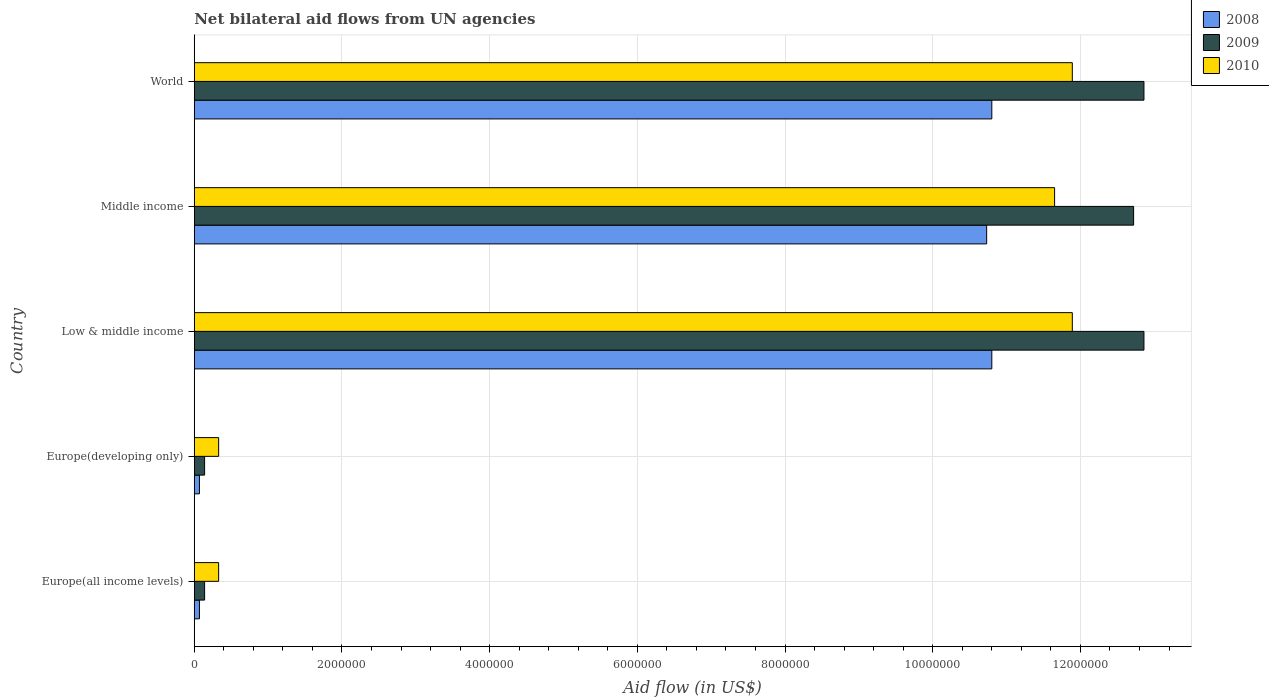How many different coloured bars are there?
Offer a very short reply. 3. Are the number of bars per tick equal to the number of legend labels?
Give a very brief answer. Yes. Are the number of bars on each tick of the Y-axis equal?
Give a very brief answer. Yes. How many bars are there on the 4th tick from the top?
Your answer should be very brief. 3. What is the label of the 3rd group of bars from the top?
Your answer should be compact. Low & middle income. Across all countries, what is the maximum net bilateral aid flow in 2010?
Offer a very short reply. 1.19e+07. Across all countries, what is the minimum net bilateral aid flow in 2010?
Provide a succinct answer. 3.30e+05. In which country was the net bilateral aid flow in 2010 maximum?
Your answer should be compact. Low & middle income. In which country was the net bilateral aid flow in 2010 minimum?
Your response must be concise. Europe(all income levels). What is the total net bilateral aid flow in 2010 in the graph?
Offer a terse response. 3.61e+07. What is the difference between the net bilateral aid flow in 2010 in Low & middle income and that in World?
Your response must be concise. 0. What is the difference between the net bilateral aid flow in 2009 in Middle income and the net bilateral aid flow in 2008 in World?
Offer a very short reply. 1.92e+06. What is the average net bilateral aid flow in 2009 per country?
Your answer should be compact. 7.74e+06. What is the ratio of the net bilateral aid flow in 2010 in Middle income to that in World?
Your answer should be compact. 0.98. Is the difference between the net bilateral aid flow in 2010 in Europe(all income levels) and World greater than the difference between the net bilateral aid flow in 2009 in Europe(all income levels) and World?
Keep it short and to the point. Yes. What is the difference between the highest and the second highest net bilateral aid flow in 2009?
Your answer should be very brief. 0. What is the difference between the highest and the lowest net bilateral aid flow in 2010?
Offer a very short reply. 1.16e+07. In how many countries, is the net bilateral aid flow in 2009 greater than the average net bilateral aid flow in 2009 taken over all countries?
Provide a succinct answer. 3. Is the sum of the net bilateral aid flow in 2008 in Europe(developing only) and World greater than the maximum net bilateral aid flow in 2010 across all countries?
Ensure brevity in your answer.  No. What does the 3rd bar from the top in Low & middle income represents?
Provide a short and direct response. 2008. What does the 3rd bar from the bottom in Middle income represents?
Provide a succinct answer. 2010. Is it the case that in every country, the sum of the net bilateral aid flow in 2010 and net bilateral aid flow in 2008 is greater than the net bilateral aid flow in 2009?
Ensure brevity in your answer.  Yes. How many countries are there in the graph?
Give a very brief answer. 5. Does the graph contain any zero values?
Provide a succinct answer. No. Does the graph contain grids?
Offer a terse response. Yes. Where does the legend appear in the graph?
Provide a succinct answer. Top right. How are the legend labels stacked?
Make the answer very short. Vertical. What is the title of the graph?
Your answer should be compact. Net bilateral aid flows from UN agencies. Does "1960" appear as one of the legend labels in the graph?
Provide a short and direct response. No. What is the label or title of the X-axis?
Offer a very short reply. Aid flow (in US$). What is the label or title of the Y-axis?
Offer a terse response. Country. What is the Aid flow (in US$) of 2008 in Europe(all income levels)?
Provide a succinct answer. 7.00e+04. What is the Aid flow (in US$) in 2009 in Europe(all income levels)?
Give a very brief answer. 1.40e+05. What is the Aid flow (in US$) of 2010 in Europe(all income levels)?
Your answer should be very brief. 3.30e+05. What is the Aid flow (in US$) of 2008 in Europe(developing only)?
Your response must be concise. 7.00e+04. What is the Aid flow (in US$) of 2008 in Low & middle income?
Your answer should be very brief. 1.08e+07. What is the Aid flow (in US$) in 2009 in Low & middle income?
Offer a terse response. 1.29e+07. What is the Aid flow (in US$) of 2010 in Low & middle income?
Provide a succinct answer. 1.19e+07. What is the Aid flow (in US$) of 2008 in Middle income?
Your answer should be very brief. 1.07e+07. What is the Aid flow (in US$) of 2009 in Middle income?
Offer a terse response. 1.27e+07. What is the Aid flow (in US$) in 2010 in Middle income?
Offer a very short reply. 1.16e+07. What is the Aid flow (in US$) in 2008 in World?
Make the answer very short. 1.08e+07. What is the Aid flow (in US$) in 2009 in World?
Keep it short and to the point. 1.29e+07. What is the Aid flow (in US$) in 2010 in World?
Provide a succinct answer. 1.19e+07. Across all countries, what is the maximum Aid flow (in US$) in 2008?
Your answer should be compact. 1.08e+07. Across all countries, what is the maximum Aid flow (in US$) of 2009?
Provide a succinct answer. 1.29e+07. Across all countries, what is the maximum Aid flow (in US$) of 2010?
Give a very brief answer. 1.19e+07. Across all countries, what is the minimum Aid flow (in US$) in 2008?
Ensure brevity in your answer.  7.00e+04. What is the total Aid flow (in US$) of 2008 in the graph?
Offer a very short reply. 3.25e+07. What is the total Aid flow (in US$) in 2009 in the graph?
Your response must be concise. 3.87e+07. What is the total Aid flow (in US$) in 2010 in the graph?
Your response must be concise. 3.61e+07. What is the difference between the Aid flow (in US$) of 2008 in Europe(all income levels) and that in Europe(developing only)?
Your response must be concise. 0. What is the difference between the Aid flow (in US$) in 2008 in Europe(all income levels) and that in Low & middle income?
Provide a succinct answer. -1.07e+07. What is the difference between the Aid flow (in US$) in 2009 in Europe(all income levels) and that in Low & middle income?
Your answer should be compact. -1.27e+07. What is the difference between the Aid flow (in US$) of 2010 in Europe(all income levels) and that in Low & middle income?
Offer a very short reply. -1.16e+07. What is the difference between the Aid flow (in US$) of 2008 in Europe(all income levels) and that in Middle income?
Keep it short and to the point. -1.07e+07. What is the difference between the Aid flow (in US$) in 2009 in Europe(all income levels) and that in Middle income?
Your answer should be very brief. -1.26e+07. What is the difference between the Aid flow (in US$) of 2010 in Europe(all income levels) and that in Middle income?
Give a very brief answer. -1.13e+07. What is the difference between the Aid flow (in US$) in 2008 in Europe(all income levels) and that in World?
Ensure brevity in your answer.  -1.07e+07. What is the difference between the Aid flow (in US$) in 2009 in Europe(all income levels) and that in World?
Give a very brief answer. -1.27e+07. What is the difference between the Aid flow (in US$) in 2010 in Europe(all income levels) and that in World?
Keep it short and to the point. -1.16e+07. What is the difference between the Aid flow (in US$) in 2008 in Europe(developing only) and that in Low & middle income?
Keep it short and to the point. -1.07e+07. What is the difference between the Aid flow (in US$) of 2009 in Europe(developing only) and that in Low & middle income?
Offer a very short reply. -1.27e+07. What is the difference between the Aid flow (in US$) of 2010 in Europe(developing only) and that in Low & middle income?
Make the answer very short. -1.16e+07. What is the difference between the Aid flow (in US$) in 2008 in Europe(developing only) and that in Middle income?
Offer a very short reply. -1.07e+07. What is the difference between the Aid flow (in US$) of 2009 in Europe(developing only) and that in Middle income?
Keep it short and to the point. -1.26e+07. What is the difference between the Aid flow (in US$) of 2010 in Europe(developing only) and that in Middle income?
Offer a terse response. -1.13e+07. What is the difference between the Aid flow (in US$) in 2008 in Europe(developing only) and that in World?
Offer a terse response. -1.07e+07. What is the difference between the Aid flow (in US$) of 2009 in Europe(developing only) and that in World?
Your answer should be very brief. -1.27e+07. What is the difference between the Aid flow (in US$) of 2010 in Europe(developing only) and that in World?
Offer a terse response. -1.16e+07. What is the difference between the Aid flow (in US$) in 2008 in Low & middle income and that in Middle income?
Give a very brief answer. 7.00e+04. What is the difference between the Aid flow (in US$) in 2009 in Low & middle income and that in Middle income?
Offer a terse response. 1.40e+05. What is the difference between the Aid flow (in US$) of 2008 in Low & middle income and that in World?
Your response must be concise. 0. What is the difference between the Aid flow (in US$) of 2009 in Low & middle income and that in World?
Make the answer very short. 0. What is the difference between the Aid flow (in US$) in 2010 in Low & middle income and that in World?
Keep it short and to the point. 0. What is the difference between the Aid flow (in US$) in 2010 in Middle income and that in World?
Ensure brevity in your answer.  -2.40e+05. What is the difference between the Aid flow (in US$) of 2009 in Europe(all income levels) and the Aid flow (in US$) of 2010 in Europe(developing only)?
Offer a very short reply. -1.90e+05. What is the difference between the Aid flow (in US$) of 2008 in Europe(all income levels) and the Aid flow (in US$) of 2009 in Low & middle income?
Ensure brevity in your answer.  -1.28e+07. What is the difference between the Aid flow (in US$) in 2008 in Europe(all income levels) and the Aid flow (in US$) in 2010 in Low & middle income?
Your answer should be very brief. -1.18e+07. What is the difference between the Aid flow (in US$) in 2009 in Europe(all income levels) and the Aid flow (in US$) in 2010 in Low & middle income?
Give a very brief answer. -1.18e+07. What is the difference between the Aid flow (in US$) of 2008 in Europe(all income levels) and the Aid flow (in US$) of 2009 in Middle income?
Offer a terse response. -1.26e+07. What is the difference between the Aid flow (in US$) of 2008 in Europe(all income levels) and the Aid flow (in US$) of 2010 in Middle income?
Your response must be concise. -1.16e+07. What is the difference between the Aid flow (in US$) of 2009 in Europe(all income levels) and the Aid flow (in US$) of 2010 in Middle income?
Offer a terse response. -1.15e+07. What is the difference between the Aid flow (in US$) of 2008 in Europe(all income levels) and the Aid flow (in US$) of 2009 in World?
Your response must be concise. -1.28e+07. What is the difference between the Aid flow (in US$) of 2008 in Europe(all income levels) and the Aid flow (in US$) of 2010 in World?
Make the answer very short. -1.18e+07. What is the difference between the Aid flow (in US$) in 2009 in Europe(all income levels) and the Aid flow (in US$) in 2010 in World?
Make the answer very short. -1.18e+07. What is the difference between the Aid flow (in US$) of 2008 in Europe(developing only) and the Aid flow (in US$) of 2009 in Low & middle income?
Offer a very short reply. -1.28e+07. What is the difference between the Aid flow (in US$) of 2008 in Europe(developing only) and the Aid flow (in US$) of 2010 in Low & middle income?
Your answer should be compact. -1.18e+07. What is the difference between the Aid flow (in US$) of 2009 in Europe(developing only) and the Aid flow (in US$) of 2010 in Low & middle income?
Give a very brief answer. -1.18e+07. What is the difference between the Aid flow (in US$) of 2008 in Europe(developing only) and the Aid flow (in US$) of 2009 in Middle income?
Your response must be concise. -1.26e+07. What is the difference between the Aid flow (in US$) in 2008 in Europe(developing only) and the Aid flow (in US$) in 2010 in Middle income?
Provide a succinct answer. -1.16e+07. What is the difference between the Aid flow (in US$) of 2009 in Europe(developing only) and the Aid flow (in US$) of 2010 in Middle income?
Offer a terse response. -1.15e+07. What is the difference between the Aid flow (in US$) in 2008 in Europe(developing only) and the Aid flow (in US$) in 2009 in World?
Provide a succinct answer. -1.28e+07. What is the difference between the Aid flow (in US$) of 2008 in Europe(developing only) and the Aid flow (in US$) of 2010 in World?
Keep it short and to the point. -1.18e+07. What is the difference between the Aid flow (in US$) of 2009 in Europe(developing only) and the Aid flow (in US$) of 2010 in World?
Make the answer very short. -1.18e+07. What is the difference between the Aid flow (in US$) in 2008 in Low & middle income and the Aid flow (in US$) in 2009 in Middle income?
Make the answer very short. -1.92e+06. What is the difference between the Aid flow (in US$) in 2008 in Low & middle income and the Aid flow (in US$) in 2010 in Middle income?
Your response must be concise. -8.50e+05. What is the difference between the Aid flow (in US$) of 2009 in Low & middle income and the Aid flow (in US$) of 2010 in Middle income?
Your answer should be very brief. 1.21e+06. What is the difference between the Aid flow (in US$) of 2008 in Low & middle income and the Aid flow (in US$) of 2009 in World?
Your answer should be very brief. -2.06e+06. What is the difference between the Aid flow (in US$) in 2008 in Low & middle income and the Aid flow (in US$) in 2010 in World?
Provide a short and direct response. -1.09e+06. What is the difference between the Aid flow (in US$) of 2009 in Low & middle income and the Aid flow (in US$) of 2010 in World?
Offer a terse response. 9.70e+05. What is the difference between the Aid flow (in US$) in 2008 in Middle income and the Aid flow (in US$) in 2009 in World?
Ensure brevity in your answer.  -2.13e+06. What is the difference between the Aid flow (in US$) in 2008 in Middle income and the Aid flow (in US$) in 2010 in World?
Offer a very short reply. -1.16e+06. What is the difference between the Aid flow (in US$) in 2009 in Middle income and the Aid flow (in US$) in 2010 in World?
Your answer should be very brief. 8.30e+05. What is the average Aid flow (in US$) in 2008 per country?
Offer a terse response. 6.49e+06. What is the average Aid flow (in US$) of 2009 per country?
Provide a short and direct response. 7.74e+06. What is the average Aid flow (in US$) of 2010 per country?
Give a very brief answer. 7.22e+06. What is the difference between the Aid flow (in US$) of 2008 and Aid flow (in US$) of 2009 in Europe(all income levels)?
Your response must be concise. -7.00e+04. What is the difference between the Aid flow (in US$) of 2008 and Aid flow (in US$) of 2010 in Europe(developing only)?
Your answer should be compact. -2.60e+05. What is the difference between the Aid flow (in US$) in 2009 and Aid flow (in US$) in 2010 in Europe(developing only)?
Offer a very short reply. -1.90e+05. What is the difference between the Aid flow (in US$) of 2008 and Aid flow (in US$) of 2009 in Low & middle income?
Your answer should be very brief. -2.06e+06. What is the difference between the Aid flow (in US$) in 2008 and Aid flow (in US$) in 2010 in Low & middle income?
Keep it short and to the point. -1.09e+06. What is the difference between the Aid flow (in US$) in 2009 and Aid flow (in US$) in 2010 in Low & middle income?
Offer a very short reply. 9.70e+05. What is the difference between the Aid flow (in US$) of 2008 and Aid flow (in US$) of 2009 in Middle income?
Provide a short and direct response. -1.99e+06. What is the difference between the Aid flow (in US$) of 2008 and Aid flow (in US$) of 2010 in Middle income?
Your answer should be compact. -9.20e+05. What is the difference between the Aid flow (in US$) of 2009 and Aid flow (in US$) of 2010 in Middle income?
Make the answer very short. 1.07e+06. What is the difference between the Aid flow (in US$) in 2008 and Aid flow (in US$) in 2009 in World?
Your answer should be compact. -2.06e+06. What is the difference between the Aid flow (in US$) of 2008 and Aid flow (in US$) of 2010 in World?
Provide a short and direct response. -1.09e+06. What is the difference between the Aid flow (in US$) of 2009 and Aid flow (in US$) of 2010 in World?
Make the answer very short. 9.70e+05. What is the ratio of the Aid flow (in US$) in 2008 in Europe(all income levels) to that in Low & middle income?
Provide a short and direct response. 0.01. What is the ratio of the Aid flow (in US$) in 2009 in Europe(all income levels) to that in Low & middle income?
Keep it short and to the point. 0.01. What is the ratio of the Aid flow (in US$) in 2010 in Europe(all income levels) to that in Low & middle income?
Keep it short and to the point. 0.03. What is the ratio of the Aid flow (in US$) in 2008 in Europe(all income levels) to that in Middle income?
Provide a short and direct response. 0.01. What is the ratio of the Aid flow (in US$) in 2009 in Europe(all income levels) to that in Middle income?
Make the answer very short. 0.01. What is the ratio of the Aid flow (in US$) of 2010 in Europe(all income levels) to that in Middle income?
Keep it short and to the point. 0.03. What is the ratio of the Aid flow (in US$) of 2008 in Europe(all income levels) to that in World?
Your answer should be compact. 0.01. What is the ratio of the Aid flow (in US$) of 2009 in Europe(all income levels) to that in World?
Offer a terse response. 0.01. What is the ratio of the Aid flow (in US$) in 2010 in Europe(all income levels) to that in World?
Give a very brief answer. 0.03. What is the ratio of the Aid flow (in US$) in 2008 in Europe(developing only) to that in Low & middle income?
Your answer should be compact. 0.01. What is the ratio of the Aid flow (in US$) in 2009 in Europe(developing only) to that in Low & middle income?
Give a very brief answer. 0.01. What is the ratio of the Aid flow (in US$) of 2010 in Europe(developing only) to that in Low & middle income?
Provide a succinct answer. 0.03. What is the ratio of the Aid flow (in US$) in 2008 in Europe(developing only) to that in Middle income?
Give a very brief answer. 0.01. What is the ratio of the Aid flow (in US$) in 2009 in Europe(developing only) to that in Middle income?
Keep it short and to the point. 0.01. What is the ratio of the Aid flow (in US$) of 2010 in Europe(developing only) to that in Middle income?
Provide a succinct answer. 0.03. What is the ratio of the Aid flow (in US$) in 2008 in Europe(developing only) to that in World?
Ensure brevity in your answer.  0.01. What is the ratio of the Aid flow (in US$) in 2009 in Europe(developing only) to that in World?
Make the answer very short. 0.01. What is the ratio of the Aid flow (in US$) of 2010 in Europe(developing only) to that in World?
Provide a short and direct response. 0.03. What is the ratio of the Aid flow (in US$) of 2009 in Low & middle income to that in Middle income?
Provide a short and direct response. 1.01. What is the ratio of the Aid flow (in US$) in 2010 in Low & middle income to that in Middle income?
Give a very brief answer. 1.02. What is the ratio of the Aid flow (in US$) in 2010 in Low & middle income to that in World?
Offer a very short reply. 1. What is the ratio of the Aid flow (in US$) of 2009 in Middle income to that in World?
Make the answer very short. 0.99. What is the ratio of the Aid flow (in US$) of 2010 in Middle income to that in World?
Provide a short and direct response. 0.98. What is the difference between the highest and the second highest Aid flow (in US$) of 2010?
Make the answer very short. 0. What is the difference between the highest and the lowest Aid flow (in US$) of 2008?
Your answer should be compact. 1.07e+07. What is the difference between the highest and the lowest Aid flow (in US$) in 2009?
Your response must be concise. 1.27e+07. What is the difference between the highest and the lowest Aid flow (in US$) in 2010?
Provide a short and direct response. 1.16e+07. 